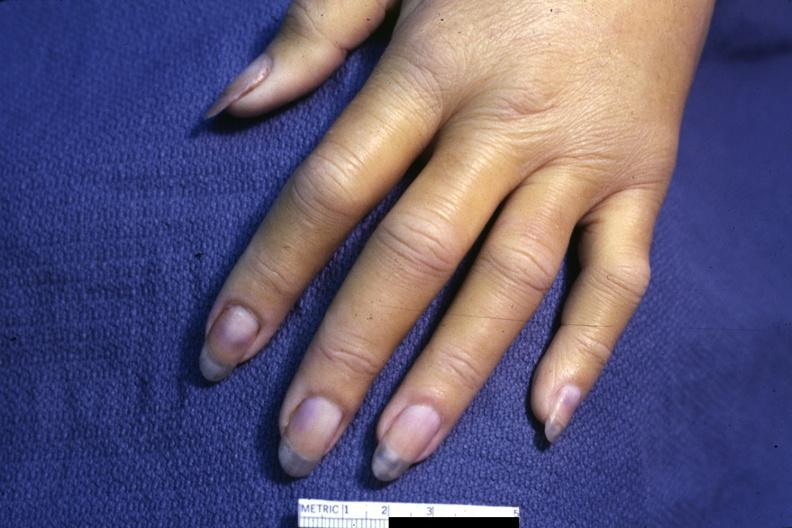does case of dic not bad photo require dark room to see subtle distal phalangeal cyanosis?
Answer the question using a single word or phrase. Yes 